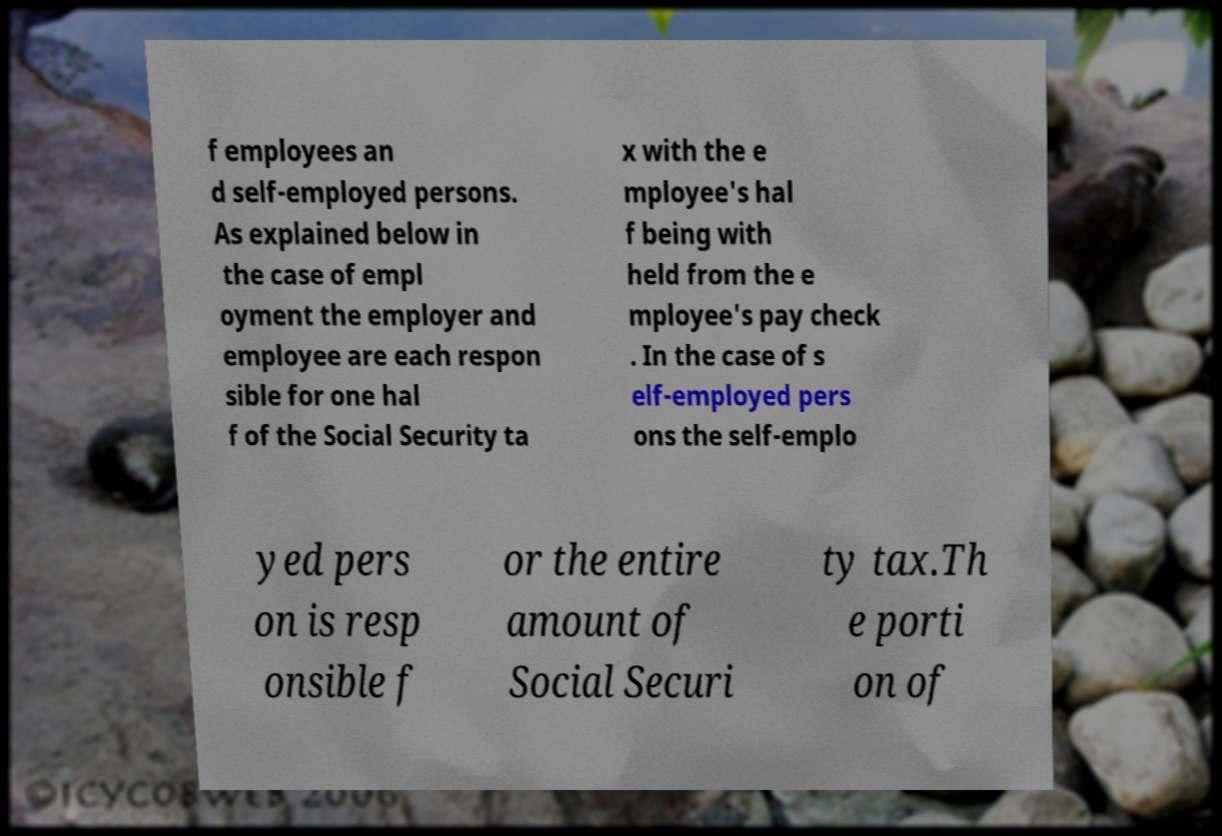I need the written content from this picture converted into text. Can you do that? f employees an d self-employed persons. As explained below in the case of empl oyment the employer and employee are each respon sible for one hal f of the Social Security ta x with the e mployee's hal f being with held from the e mployee's pay check . In the case of s elf-employed pers ons the self-emplo yed pers on is resp onsible f or the entire amount of Social Securi ty tax.Th e porti on of 